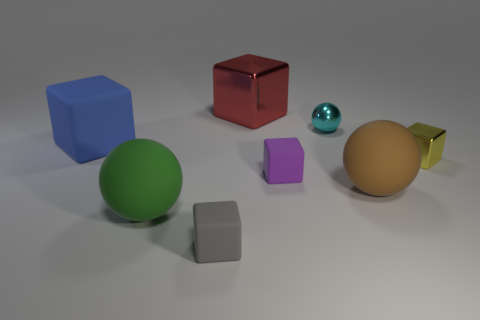Can you describe the shapes and colors of the objects in the image? Certainly! The image contains a variety of geometric shapes. There's a large green sphere, a medium-sized brown ball with a matte finish, a small blue cube, a small gray cube, a small purple cube, a red cube that's a bit larger, and a small gold cube. The colors vary from vibrant to muted, giving a diverse visual spectrum. 